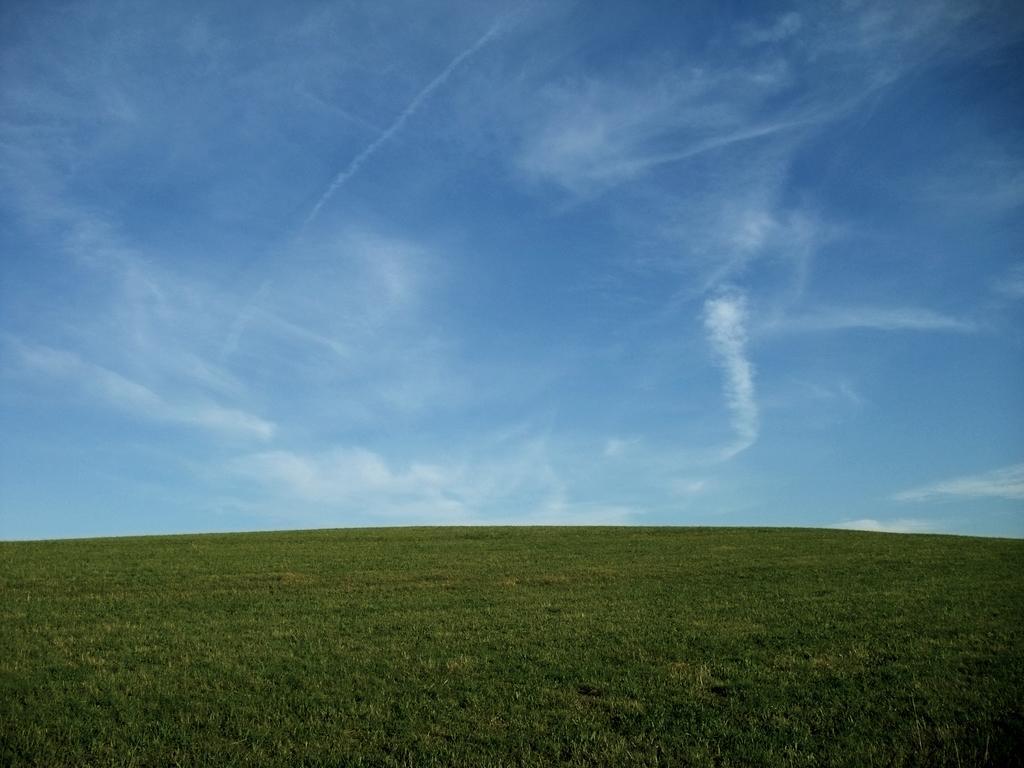Can you describe this image briefly? In this picture there is grass. At the top there is sky and there are clouds. 